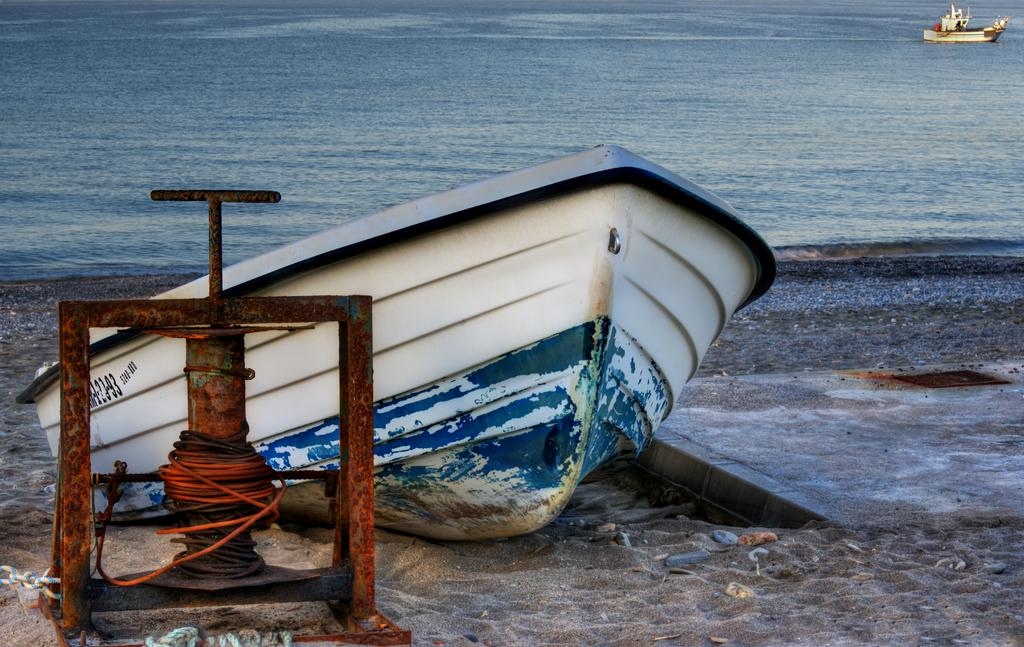What type of object is located on the left side of the image? There is a metal object on the left side of the image. What can be seen in the middle of the image? There is a boat on the sand in the middle of the image. What is happening on the right side of the image? There is a boat in the sea on the right side of the image. What type of rest can be seen in the image? There is no rest present in the image; it features a metal object, a boat on the sand, and a boat in the sea. What type of seat is available for passengers in the image? There is no mention of a seat or passengers in the image; it only shows a metal object, a boat on the sand, and a boat in the sea. 